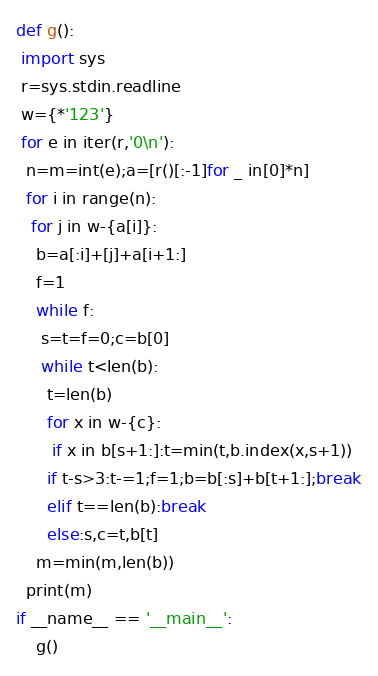<code> <loc_0><loc_0><loc_500><loc_500><_Python_>def g():
 import sys
 r=sys.stdin.readline
 w={*'123'}
 for e in iter(r,'0\n'):
  n=m=int(e);a=[r()[:-1]for _ in[0]*n]
  for i in range(n):
   for j in w-{a[i]}:
    b=a[:i]+[j]+a[i+1:]
    f=1
    while f:
     s=t=f=0;c=b[0]
     while t<len(b):
      t=len(b)
      for x in w-{c}:
       if x in b[s+1:]:t=min(t,b.index(x,s+1))
      if t-s>3:t-=1;f=1;b=b[:s]+b[t+1:];break
      elif t==len(b):break
      else:s,c=t,b[t]
    m=min(m,len(b))
  print(m)
if __name__ == '__main__':
    g()
</code> 